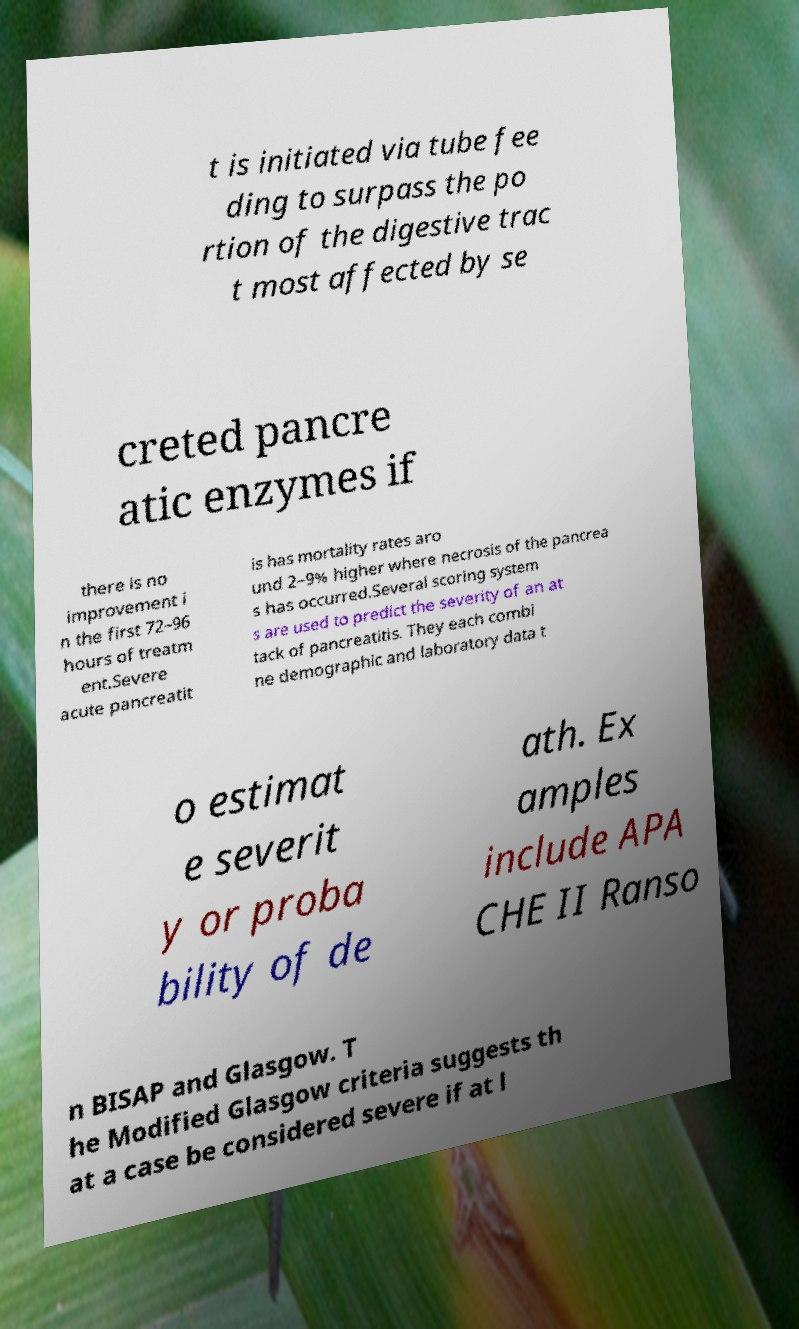What messages or text are displayed in this image? I need them in a readable, typed format. t is initiated via tube fee ding to surpass the po rtion of the digestive trac t most affected by se creted pancre atic enzymes if there is no improvement i n the first 72–96 hours of treatm ent.Severe acute pancreatit is has mortality rates aro und 2–9% higher where necrosis of the pancrea s has occurred.Several scoring system s are used to predict the severity of an at tack of pancreatitis. They each combi ne demographic and laboratory data t o estimat e severit y or proba bility of de ath. Ex amples include APA CHE II Ranso n BISAP and Glasgow. T he Modified Glasgow criteria suggests th at a case be considered severe if at l 